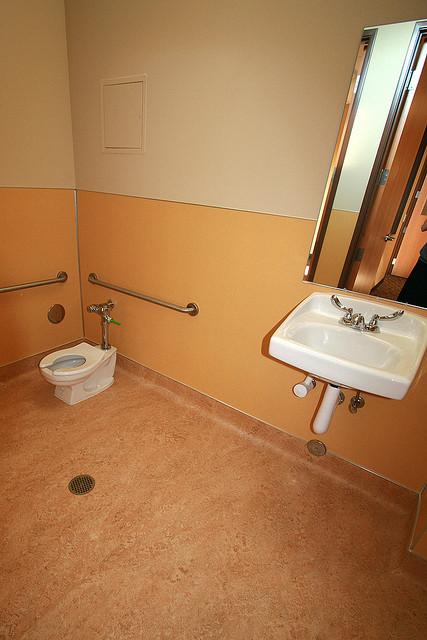Is the toilet standard size?
Quick response, please. No. Is this bathroom handicap accessible?
Give a very brief answer. Yes. What color is the lower part of the wall?
Quick response, please. Orange. 